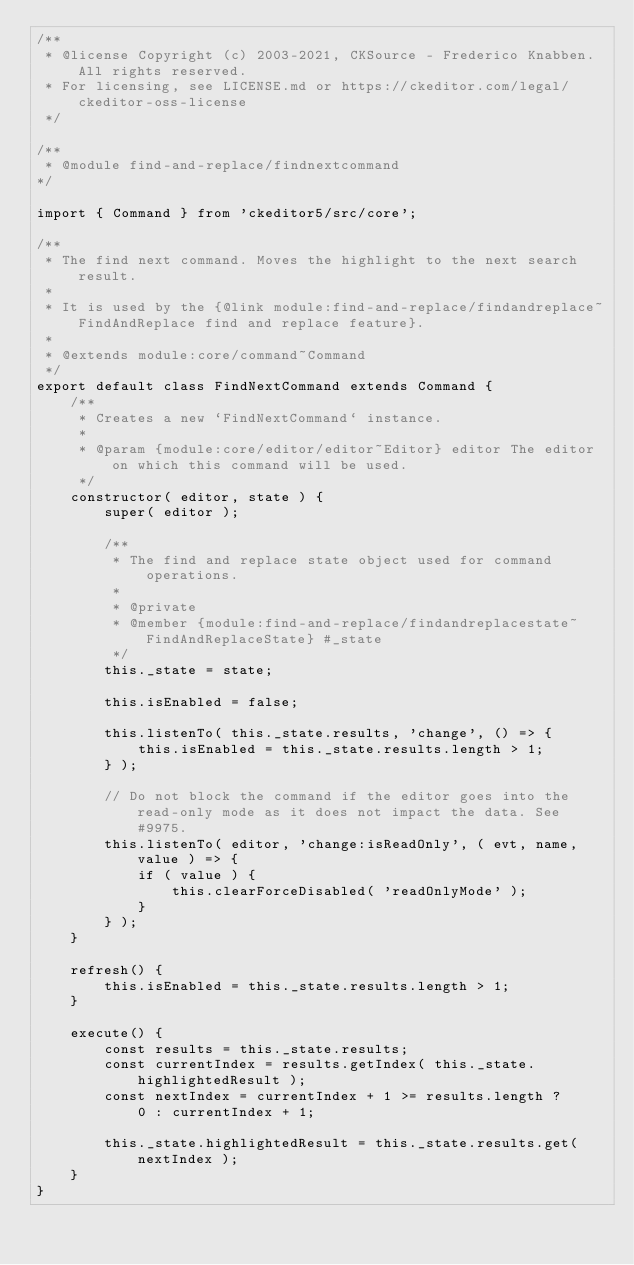Convert code to text. <code><loc_0><loc_0><loc_500><loc_500><_JavaScript_>/**
 * @license Copyright (c) 2003-2021, CKSource - Frederico Knabben. All rights reserved.
 * For licensing, see LICENSE.md or https://ckeditor.com/legal/ckeditor-oss-license
 */

/**
 * @module find-and-replace/findnextcommand
*/

import { Command } from 'ckeditor5/src/core';

/**
 * The find next command. Moves the highlight to the next search result.
 *
 * It is used by the {@link module:find-and-replace/findandreplace~FindAndReplace find and replace feature}.
 *
 * @extends module:core/command~Command
 */
export default class FindNextCommand extends Command {
	/**
	 * Creates a new `FindNextCommand` instance.
	 *
	 * @param {module:core/editor/editor~Editor} editor The editor on which this command will be used.
	 */
	constructor( editor, state ) {
		super( editor );

		/**
		 * The find and replace state object used for command operations.
		 *
		 * @private
		 * @member {module:find-and-replace/findandreplacestate~FindAndReplaceState} #_state
		 */
		this._state = state;

		this.isEnabled = false;

		this.listenTo( this._state.results, 'change', () => {
			this.isEnabled = this._state.results.length > 1;
		} );

		// Do not block the command if the editor goes into the read-only mode as it does not impact the data. See #9975.
		this.listenTo( editor, 'change:isReadOnly', ( evt, name, value ) => {
			if ( value ) {
				this.clearForceDisabled( 'readOnlyMode' );
			}
		} );
	}

	refresh() {
		this.isEnabled = this._state.results.length > 1;
	}

	execute() {
		const results = this._state.results;
		const currentIndex = results.getIndex( this._state.highlightedResult );
		const nextIndex = currentIndex + 1 >= results.length ?
			0 : currentIndex + 1;

		this._state.highlightedResult = this._state.results.get( nextIndex );
	}
}
</code> 